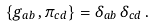Convert formula to latex. <formula><loc_0><loc_0><loc_500><loc_500>\{ g _ { a b } \, , \pi _ { c d } \} = \delta _ { a b } \, \delta _ { c d } \, .</formula> 